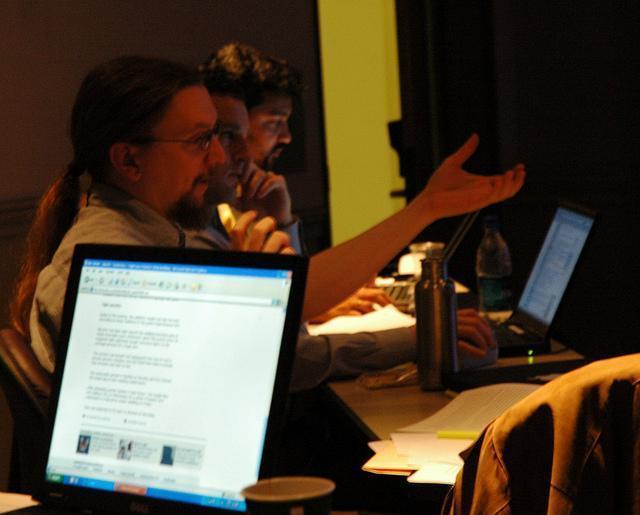How many laptops are there?
Give a very brief answer. 3. How many people are there?
Give a very brief answer. 3. How many bottles are there?
Give a very brief answer. 2. How many chairs are in the photo?
Give a very brief answer. 2. 